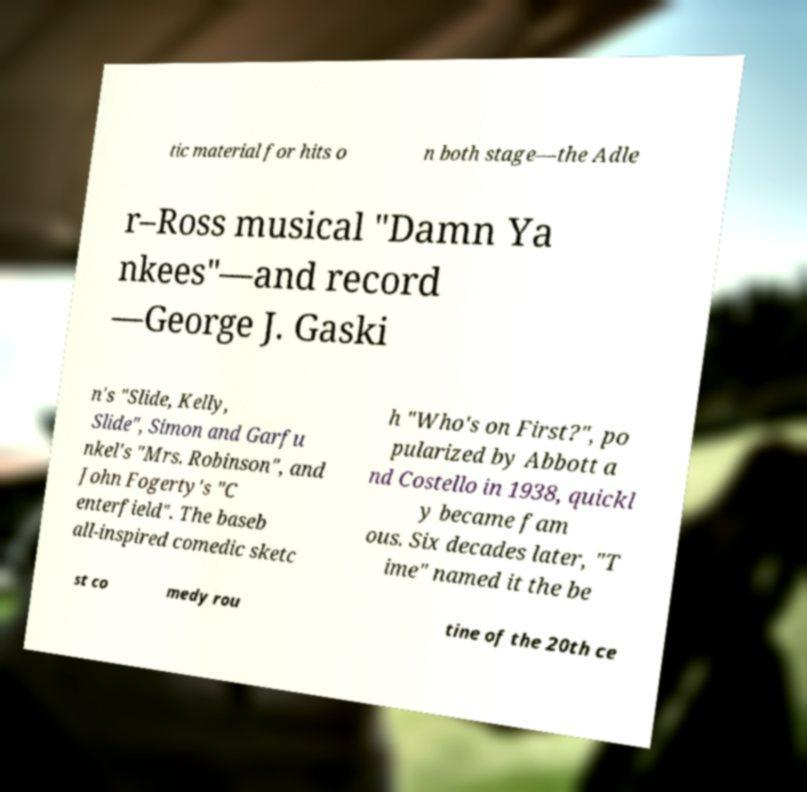Can you accurately transcribe the text from the provided image for me? tic material for hits o n both stage—the Adle r–Ross musical "Damn Ya nkees"—and record —George J. Gaski n's "Slide, Kelly, Slide", Simon and Garfu nkel's "Mrs. Robinson", and John Fogerty's "C enterfield". The baseb all-inspired comedic sketc h "Who's on First?", po pularized by Abbott a nd Costello in 1938, quickl y became fam ous. Six decades later, "T ime" named it the be st co medy rou tine of the 20th ce 